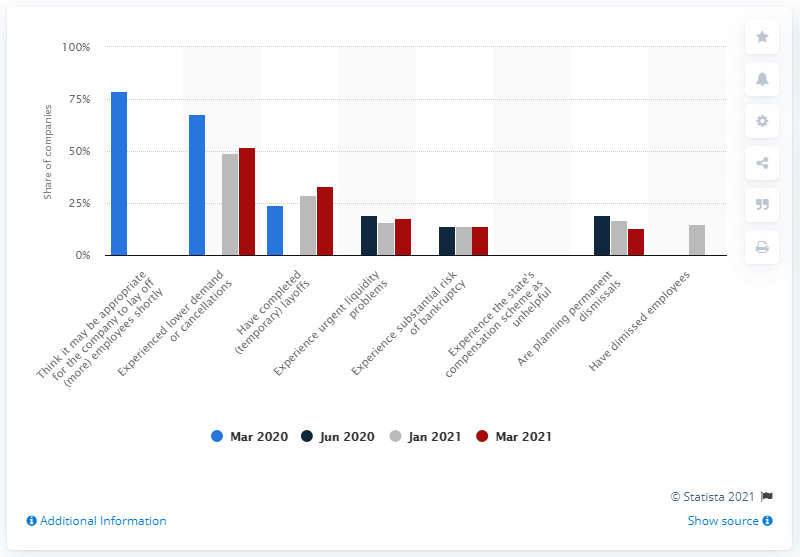Outline some significant characteristics in this image. According to a report, approximately 52% of companies experienced a decrease in demand or cancellations in March 2021. 